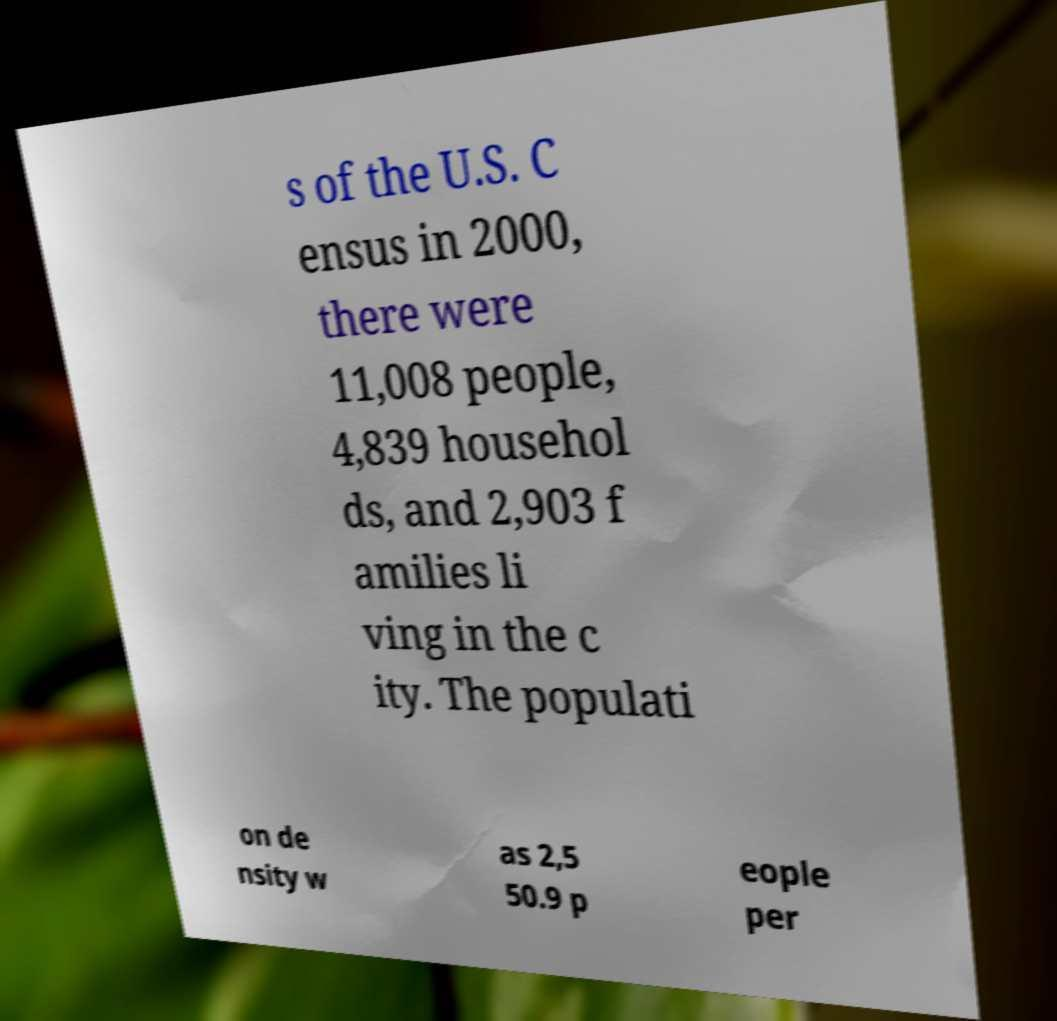There's text embedded in this image that I need extracted. Can you transcribe it verbatim? s of the U.S. C ensus in 2000, there were 11,008 people, 4,839 househol ds, and 2,903 f amilies li ving in the c ity. The populati on de nsity w as 2,5 50.9 p eople per 